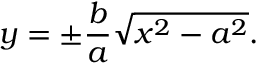<formula> <loc_0><loc_0><loc_500><loc_500>y = \pm { \frac { b } { a } } { \sqrt { x ^ { 2 } - a ^ { 2 } } } .</formula> 